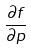<formula> <loc_0><loc_0><loc_500><loc_500>\frac { \partial f } { \partial p }</formula> 